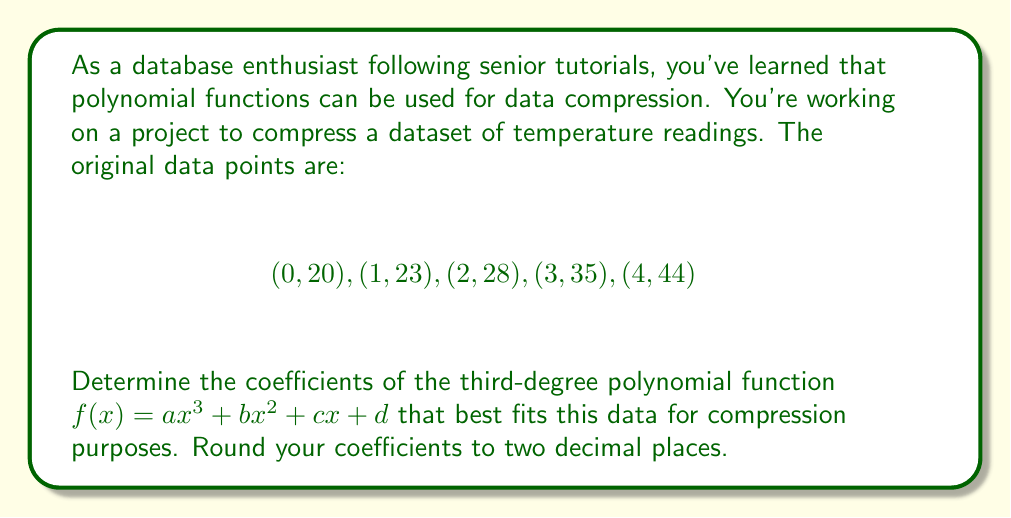Give your solution to this math problem. To find the optimal polynomial function for data compression, we'll use the method of least squares to fit a third-degree polynomial to the given data points. Here's the step-by-step process:

1) Set up the system of normal equations:
   $$\begin{bmatrix}
   \sum x^6 & \sum x^5 & \sum x^4 & \sum x^3 \\
   \sum x^5 & \sum x^4 & \sum x^3 & \sum x^2 \\
   \sum x^4 & \sum x^3 & \sum x^2 & \sum x \\
   \sum x^3 & \sum x^2 & \sum x & n
   \end{bmatrix}
   \begin{bmatrix}
   a \\ b \\ c \\ d
   \end{bmatrix} =
   \begin{bmatrix}
   \sum yx^3 \\ \sum yx^2 \\ \sum yx \\ \sum y
   \end{bmatrix}$$

2) Calculate the sums:
   $\sum x^6 = 354$, $\sum x^5 = 204$, $\sum x^4 = 130$, $\sum x^3 = 90$
   $\sum x^2 = 70$, $\sum x = 10$, $n = 5$
   $\sum yx^3 = 1170$, $\sum yx^2 = 726$, $\sum yx = 410$, $\sum y = 150$

3) Substitute these values into the system:
   $$\begin{bmatrix}
   354 & 204 & 130 & 90 \\
   204 & 130 & 90 & 70 \\
   130 & 90 & 70 & 10 \\
   90 & 70 & 10 & 5
   \end{bmatrix}
   \begin{bmatrix}
   a \\ b \\ c \\ d
   \end{bmatrix} =
   \begin{bmatrix}
   1170 \\ 726 \\ 410 \\ 150
   \end{bmatrix}$$

4) Solve this system using Gaussian elimination or matrix inversion.

5) The solution gives us the coefficients:
   $a \approx 0.5$
   $b \approx -0.5$
   $c \approx 4$
   $d \approx 20$

Therefore, the optimal third-degree polynomial function for compressing this data is:

$$f(x) = 0.5x^3 - 0.5x^2 + 4x + 20$$

This polynomial can now be used to compress the temperature data by storing only the coefficients instead of all data points.
Answer: $f(x) = 0.50x^3 - 0.50x^2 + 4.00x + 20.00$ 